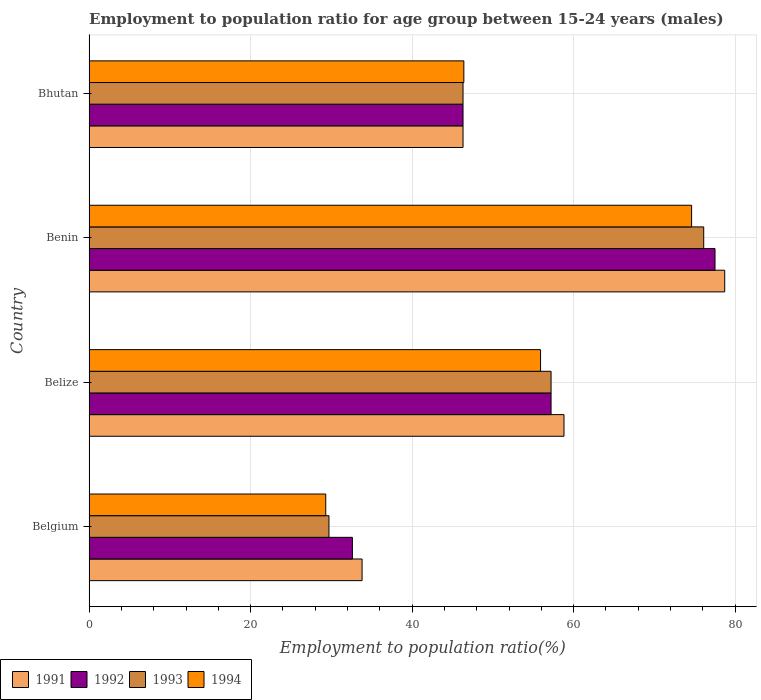How many different coloured bars are there?
Ensure brevity in your answer.  4. How many groups of bars are there?
Provide a succinct answer. 4. How many bars are there on the 2nd tick from the top?
Offer a terse response. 4. How many bars are there on the 2nd tick from the bottom?
Your response must be concise. 4. What is the label of the 2nd group of bars from the top?
Give a very brief answer. Benin. What is the employment to population ratio in 1991 in Benin?
Give a very brief answer. 78.7. Across all countries, what is the maximum employment to population ratio in 1994?
Ensure brevity in your answer.  74.6. Across all countries, what is the minimum employment to population ratio in 1991?
Ensure brevity in your answer.  33.8. In which country was the employment to population ratio in 1991 maximum?
Your answer should be compact. Benin. In which country was the employment to population ratio in 1994 minimum?
Make the answer very short. Belgium. What is the total employment to population ratio in 1991 in the graph?
Your answer should be very brief. 217.6. What is the difference between the employment to population ratio in 1994 in Belgium and that in Benin?
Give a very brief answer. -45.3. What is the difference between the employment to population ratio in 1994 in Belize and the employment to population ratio in 1992 in Belgium?
Provide a succinct answer. 23.3. What is the average employment to population ratio in 1992 per country?
Provide a succinct answer. 53.4. What is the difference between the employment to population ratio in 1994 and employment to population ratio in 1991 in Bhutan?
Provide a succinct answer. 0.1. In how many countries, is the employment to population ratio in 1993 greater than 68 %?
Your answer should be very brief. 1. What is the ratio of the employment to population ratio in 1991 in Benin to that in Bhutan?
Provide a succinct answer. 1.7. What is the difference between the highest and the second highest employment to population ratio in 1991?
Ensure brevity in your answer.  19.9. What is the difference between the highest and the lowest employment to population ratio in 1994?
Your response must be concise. 45.3. Is it the case that in every country, the sum of the employment to population ratio in 1993 and employment to population ratio in 1991 is greater than the sum of employment to population ratio in 1994 and employment to population ratio in 1992?
Keep it short and to the point. No. What does the 4th bar from the bottom in Benin represents?
Give a very brief answer. 1994. How many bars are there?
Provide a short and direct response. 16. Are all the bars in the graph horizontal?
Offer a terse response. Yes. How many countries are there in the graph?
Provide a short and direct response. 4. Where does the legend appear in the graph?
Make the answer very short. Bottom left. How many legend labels are there?
Provide a succinct answer. 4. How are the legend labels stacked?
Ensure brevity in your answer.  Horizontal. What is the title of the graph?
Provide a short and direct response. Employment to population ratio for age group between 15-24 years (males). What is the label or title of the X-axis?
Your answer should be compact. Employment to population ratio(%). What is the label or title of the Y-axis?
Provide a short and direct response. Country. What is the Employment to population ratio(%) in 1991 in Belgium?
Keep it short and to the point. 33.8. What is the Employment to population ratio(%) in 1992 in Belgium?
Ensure brevity in your answer.  32.6. What is the Employment to population ratio(%) of 1993 in Belgium?
Keep it short and to the point. 29.7. What is the Employment to population ratio(%) in 1994 in Belgium?
Give a very brief answer. 29.3. What is the Employment to population ratio(%) of 1991 in Belize?
Give a very brief answer. 58.8. What is the Employment to population ratio(%) in 1992 in Belize?
Ensure brevity in your answer.  57.2. What is the Employment to population ratio(%) of 1993 in Belize?
Your answer should be very brief. 57.2. What is the Employment to population ratio(%) of 1994 in Belize?
Ensure brevity in your answer.  55.9. What is the Employment to population ratio(%) of 1991 in Benin?
Keep it short and to the point. 78.7. What is the Employment to population ratio(%) in 1992 in Benin?
Ensure brevity in your answer.  77.5. What is the Employment to population ratio(%) in 1993 in Benin?
Your answer should be very brief. 76.1. What is the Employment to population ratio(%) in 1994 in Benin?
Give a very brief answer. 74.6. What is the Employment to population ratio(%) in 1991 in Bhutan?
Provide a short and direct response. 46.3. What is the Employment to population ratio(%) in 1992 in Bhutan?
Ensure brevity in your answer.  46.3. What is the Employment to population ratio(%) in 1993 in Bhutan?
Your answer should be compact. 46.3. What is the Employment to population ratio(%) of 1994 in Bhutan?
Give a very brief answer. 46.4. Across all countries, what is the maximum Employment to population ratio(%) of 1991?
Your response must be concise. 78.7. Across all countries, what is the maximum Employment to population ratio(%) of 1992?
Your response must be concise. 77.5. Across all countries, what is the maximum Employment to population ratio(%) in 1993?
Offer a very short reply. 76.1. Across all countries, what is the maximum Employment to population ratio(%) in 1994?
Provide a short and direct response. 74.6. Across all countries, what is the minimum Employment to population ratio(%) in 1991?
Give a very brief answer. 33.8. Across all countries, what is the minimum Employment to population ratio(%) of 1992?
Your answer should be compact. 32.6. Across all countries, what is the minimum Employment to population ratio(%) in 1993?
Offer a very short reply. 29.7. Across all countries, what is the minimum Employment to population ratio(%) in 1994?
Your answer should be compact. 29.3. What is the total Employment to population ratio(%) in 1991 in the graph?
Make the answer very short. 217.6. What is the total Employment to population ratio(%) of 1992 in the graph?
Your answer should be compact. 213.6. What is the total Employment to population ratio(%) in 1993 in the graph?
Ensure brevity in your answer.  209.3. What is the total Employment to population ratio(%) in 1994 in the graph?
Ensure brevity in your answer.  206.2. What is the difference between the Employment to population ratio(%) of 1991 in Belgium and that in Belize?
Your answer should be very brief. -25. What is the difference between the Employment to population ratio(%) of 1992 in Belgium and that in Belize?
Provide a short and direct response. -24.6. What is the difference between the Employment to population ratio(%) in 1993 in Belgium and that in Belize?
Ensure brevity in your answer.  -27.5. What is the difference between the Employment to population ratio(%) in 1994 in Belgium and that in Belize?
Your answer should be very brief. -26.6. What is the difference between the Employment to population ratio(%) in 1991 in Belgium and that in Benin?
Keep it short and to the point. -44.9. What is the difference between the Employment to population ratio(%) of 1992 in Belgium and that in Benin?
Make the answer very short. -44.9. What is the difference between the Employment to population ratio(%) of 1993 in Belgium and that in Benin?
Provide a succinct answer. -46.4. What is the difference between the Employment to population ratio(%) in 1994 in Belgium and that in Benin?
Your answer should be compact. -45.3. What is the difference between the Employment to population ratio(%) of 1991 in Belgium and that in Bhutan?
Your answer should be very brief. -12.5. What is the difference between the Employment to population ratio(%) in 1992 in Belgium and that in Bhutan?
Keep it short and to the point. -13.7. What is the difference between the Employment to population ratio(%) of 1993 in Belgium and that in Bhutan?
Your answer should be very brief. -16.6. What is the difference between the Employment to population ratio(%) in 1994 in Belgium and that in Bhutan?
Make the answer very short. -17.1. What is the difference between the Employment to population ratio(%) in 1991 in Belize and that in Benin?
Provide a succinct answer. -19.9. What is the difference between the Employment to population ratio(%) in 1992 in Belize and that in Benin?
Give a very brief answer. -20.3. What is the difference between the Employment to population ratio(%) in 1993 in Belize and that in Benin?
Make the answer very short. -18.9. What is the difference between the Employment to population ratio(%) of 1994 in Belize and that in Benin?
Offer a terse response. -18.7. What is the difference between the Employment to population ratio(%) of 1992 in Belize and that in Bhutan?
Ensure brevity in your answer.  10.9. What is the difference between the Employment to population ratio(%) of 1994 in Belize and that in Bhutan?
Offer a very short reply. 9.5. What is the difference between the Employment to population ratio(%) in 1991 in Benin and that in Bhutan?
Provide a succinct answer. 32.4. What is the difference between the Employment to population ratio(%) of 1992 in Benin and that in Bhutan?
Keep it short and to the point. 31.2. What is the difference between the Employment to population ratio(%) of 1993 in Benin and that in Bhutan?
Provide a succinct answer. 29.8. What is the difference between the Employment to population ratio(%) in 1994 in Benin and that in Bhutan?
Offer a very short reply. 28.2. What is the difference between the Employment to population ratio(%) of 1991 in Belgium and the Employment to population ratio(%) of 1992 in Belize?
Offer a very short reply. -23.4. What is the difference between the Employment to population ratio(%) of 1991 in Belgium and the Employment to population ratio(%) of 1993 in Belize?
Provide a short and direct response. -23.4. What is the difference between the Employment to population ratio(%) of 1991 in Belgium and the Employment to population ratio(%) of 1994 in Belize?
Offer a terse response. -22.1. What is the difference between the Employment to population ratio(%) in 1992 in Belgium and the Employment to population ratio(%) in 1993 in Belize?
Keep it short and to the point. -24.6. What is the difference between the Employment to population ratio(%) of 1992 in Belgium and the Employment to population ratio(%) of 1994 in Belize?
Your answer should be compact. -23.3. What is the difference between the Employment to population ratio(%) of 1993 in Belgium and the Employment to population ratio(%) of 1994 in Belize?
Give a very brief answer. -26.2. What is the difference between the Employment to population ratio(%) in 1991 in Belgium and the Employment to population ratio(%) in 1992 in Benin?
Keep it short and to the point. -43.7. What is the difference between the Employment to population ratio(%) of 1991 in Belgium and the Employment to population ratio(%) of 1993 in Benin?
Keep it short and to the point. -42.3. What is the difference between the Employment to population ratio(%) in 1991 in Belgium and the Employment to population ratio(%) in 1994 in Benin?
Your answer should be very brief. -40.8. What is the difference between the Employment to population ratio(%) in 1992 in Belgium and the Employment to population ratio(%) in 1993 in Benin?
Your response must be concise. -43.5. What is the difference between the Employment to population ratio(%) in 1992 in Belgium and the Employment to population ratio(%) in 1994 in Benin?
Give a very brief answer. -42. What is the difference between the Employment to population ratio(%) of 1993 in Belgium and the Employment to population ratio(%) of 1994 in Benin?
Make the answer very short. -44.9. What is the difference between the Employment to population ratio(%) in 1991 in Belgium and the Employment to population ratio(%) in 1992 in Bhutan?
Offer a very short reply. -12.5. What is the difference between the Employment to population ratio(%) in 1991 in Belgium and the Employment to population ratio(%) in 1993 in Bhutan?
Provide a succinct answer. -12.5. What is the difference between the Employment to population ratio(%) in 1992 in Belgium and the Employment to population ratio(%) in 1993 in Bhutan?
Keep it short and to the point. -13.7. What is the difference between the Employment to population ratio(%) of 1992 in Belgium and the Employment to population ratio(%) of 1994 in Bhutan?
Provide a short and direct response. -13.8. What is the difference between the Employment to population ratio(%) of 1993 in Belgium and the Employment to population ratio(%) of 1994 in Bhutan?
Make the answer very short. -16.7. What is the difference between the Employment to population ratio(%) of 1991 in Belize and the Employment to population ratio(%) of 1992 in Benin?
Give a very brief answer. -18.7. What is the difference between the Employment to population ratio(%) in 1991 in Belize and the Employment to population ratio(%) in 1993 in Benin?
Provide a short and direct response. -17.3. What is the difference between the Employment to population ratio(%) of 1991 in Belize and the Employment to population ratio(%) of 1994 in Benin?
Give a very brief answer. -15.8. What is the difference between the Employment to population ratio(%) in 1992 in Belize and the Employment to population ratio(%) in 1993 in Benin?
Give a very brief answer. -18.9. What is the difference between the Employment to population ratio(%) of 1992 in Belize and the Employment to population ratio(%) of 1994 in Benin?
Your response must be concise. -17.4. What is the difference between the Employment to population ratio(%) of 1993 in Belize and the Employment to population ratio(%) of 1994 in Benin?
Provide a succinct answer. -17.4. What is the difference between the Employment to population ratio(%) of 1991 in Belize and the Employment to population ratio(%) of 1992 in Bhutan?
Make the answer very short. 12.5. What is the difference between the Employment to population ratio(%) in 1991 in Belize and the Employment to population ratio(%) in 1994 in Bhutan?
Offer a very short reply. 12.4. What is the difference between the Employment to population ratio(%) of 1991 in Benin and the Employment to population ratio(%) of 1992 in Bhutan?
Keep it short and to the point. 32.4. What is the difference between the Employment to population ratio(%) of 1991 in Benin and the Employment to population ratio(%) of 1993 in Bhutan?
Keep it short and to the point. 32.4. What is the difference between the Employment to population ratio(%) of 1991 in Benin and the Employment to population ratio(%) of 1994 in Bhutan?
Offer a very short reply. 32.3. What is the difference between the Employment to population ratio(%) in 1992 in Benin and the Employment to population ratio(%) in 1993 in Bhutan?
Offer a terse response. 31.2. What is the difference between the Employment to population ratio(%) of 1992 in Benin and the Employment to population ratio(%) of 1994 in Bhutan?
Make the answer very short. 31.1. What is the difference between the Employment to population ratio(%) of 1993 in Benin and the Employment to population ratio(%) of 1994 in Bhutan?
Offer a terse response. 29.7. What is the average Employment to population ratio(%) of 1991 per country?
Your response must be concise. 54.4. What is the average Employment to population ratio(%) of 1992 per country?
Make the answer very short. 53.4. What is the average Employment to population ratio(%) in 1993 per country?
Provide a short and direct response. 52.33. What is the average Employment to population ratio(%) of 1994 per country?
Your answer should be very brief. 51.55. What is the difference between the Employment to population ratio(%) in 1991 and Employment to population ratio(%) in 1993 in Belgium?
Keep it short and to the point. 4.1. What is the difference between the Employment to population ratio(%) in 1992 and Employment to population ratio(%) in 1994 in Belgium?
Keep it short and to the point. 3.3. What is the difference between the Employment to population ratio(%) of 1991 and Employment to population ratio(%) of 1992 in Belize?
Provide a succinct answer. 1.6. What is the difference between the Employment to population ratio(%) of 1991 and Employment to population ratio(%) of 1993 in Belize?
Offer a very short reply. 1.6. What is the difference between the Employment to population ratio(%) in 1991 and Employment to population ratio(%) in 1994 in Belize?
Provide a short and direct response. 2.9. What is the difference between the Employment to population ratio(%) of 1992 and Employment to population ratio(%) of 1993 in Belize?
Keep it short and to the point. 0. What is the difference between the Employment to population ratio(%) in 1992 and Employment to population ratio(%) in 1994 in Belize?
Give a very brief answer. 1.3. What is the difference between the Employment to population ratio(%) of 1991 and Employment to population ratio(%) of 1993 in Benin?
Ensure brevity in your answer.  2.6. What is the difference between the Employment to population ratio(%) in 1991 and Employment to population ratio(%) in 1992 in Bhutan?
Make the answer very short. 0. What is the difference between the Employment to population ratio(%) in 1992 and Employment to population ratio(%) in 1993 in Bhutan?
Your answer should be compact. 0. What is the ratio of the Employment to population ratio(%) of 1991 in Belgium to that in Belize?
Your answer should be very brief. 0.57. What is the ratio of the Employment to population ratio(%) in 1992 in Belgium to that in Belize?
Offer a terse response. 0.57. What is the ratio of the Employment to population ratio(%) in 1993 in Belgium to that in Belize?
Your response must be concise. 0.52. What is the ratio of the Employment to population ratio(%) in 1994 in Belgium to that in Belize?
Your answer should be very brief. 0.52. What is the ratio of the Employment to population ratio(%) in 1991 in Belgium to that in Benin?
Keep it short and to the point. 0.43. What is the ratio of the Employment to population ratio(%) in 1992 in Belgium to that in Benin?
Offer a terse response. 0.42. What is the ratio of the Employment to population ratio(%) in 1993 in Belgium to that in Benin?
Offer a terse response. 0.39. What is the ratio of the Employment to population ratio(%) of 1994 in Belgium to that in Benin?
Make the answer very short. 0.39. What is the ratio of the Employment to population ratio(%) in 1991 in Belgium to that in Bhutan?
Give a very brief answer. 0.73. What is the ratio of the Employment to population ratio(%) in 1992 in Belgium to that in Bhutan?
Your answer should be very brief. 0.7. What is the ratio of the Employment to population ratio(%) in 1993 in Belgium to that in Bhutan?
Make the answer very short. 0.64. What is the ratio of the Employment to population ratio(%) in 1994 in Belgium to that in Bhutan?
Give a very brief answer. 0.63. What is the ratio of the Employment to population ratio(%) in 1991 in Belize to that in Benin?
Provide a succinct answer. 0.75. What is the ratio of the Employment to population ratio(%) in 1992 in Belize to that in Benin?
Give a very brief answer. 0.74. What is the ratio of the Employment to population ratio(%) of 1993 in Belize to that in Benin?
Provide a short and direct response. 0.75. What is the ratio of the Employment to population ratio(%) of 1994 in Belize to that in Benin?
Give a very brief answer. 0.75. What is the ratio of the Employment to population ratio(%) in 1991 in Belize to that in Bhutan?
Ensure brevity in your answer.  1.27. What is the ratio of the Employment to population ratio(%) in 1992 in Belize to that in Bhutan?
Your answer should be compact. 1.24. What is the ratio of the Employment to population ratio(%) of 1993 in Belize to that in Bhutan?
Keep it short and to the point. 1.24. What is the ratio of the Employment to population ratio(%) in 1994 in Belize to that in Bhutan?
Keep it short and to the point. 1.2. What is the ratio of the Employment to population ratio(%) of 1991 in Benin to that in Bhutan?
Your answer should be compact. 1.7. What is the ratio of the Employment to population ratio(%) in 1992 in Benin to that in Bhutan?
Ensure brevity in your answer.  1.67. What is the ratio of the Employment to population ratio(%) of 1993 in Benin to that in Bhutan?
Your answer should be very brief. 1.64. What is the ratio of the Employment to population ratio(%) in 1994 in Benin to that in Bhutan?
Provide a succinct answer. 1.61. What is the difference between the highest and the second highest Employment to population ratio(%) in 1992?
Offer a terse response. 20.3. What is the difference between the highest and the second highest Employment to population ratio(%) in 1993?
Your response must be concise. 18.9. What is the difference between the highest and the second highest Employment to population ratio(%) of 1994?
Make the answer very short. 18.7. What is the difference between the highest and the lowest Employment to population ratio(%) of 1991?
Provide a succinct answer. 44.9. What is the difference between the highest and the lowest Employment to population ratio(%) of 1992?
Provide a succinct answer. 44.9. What is the difference between the highest and the lowest Employment to population ratio(%) in 1993?
Make the answer very short. 46.4. What is the difference between the highest and the lowest Employment to population ratio(%) in 1994?
Offer a terse response. 45.3. 